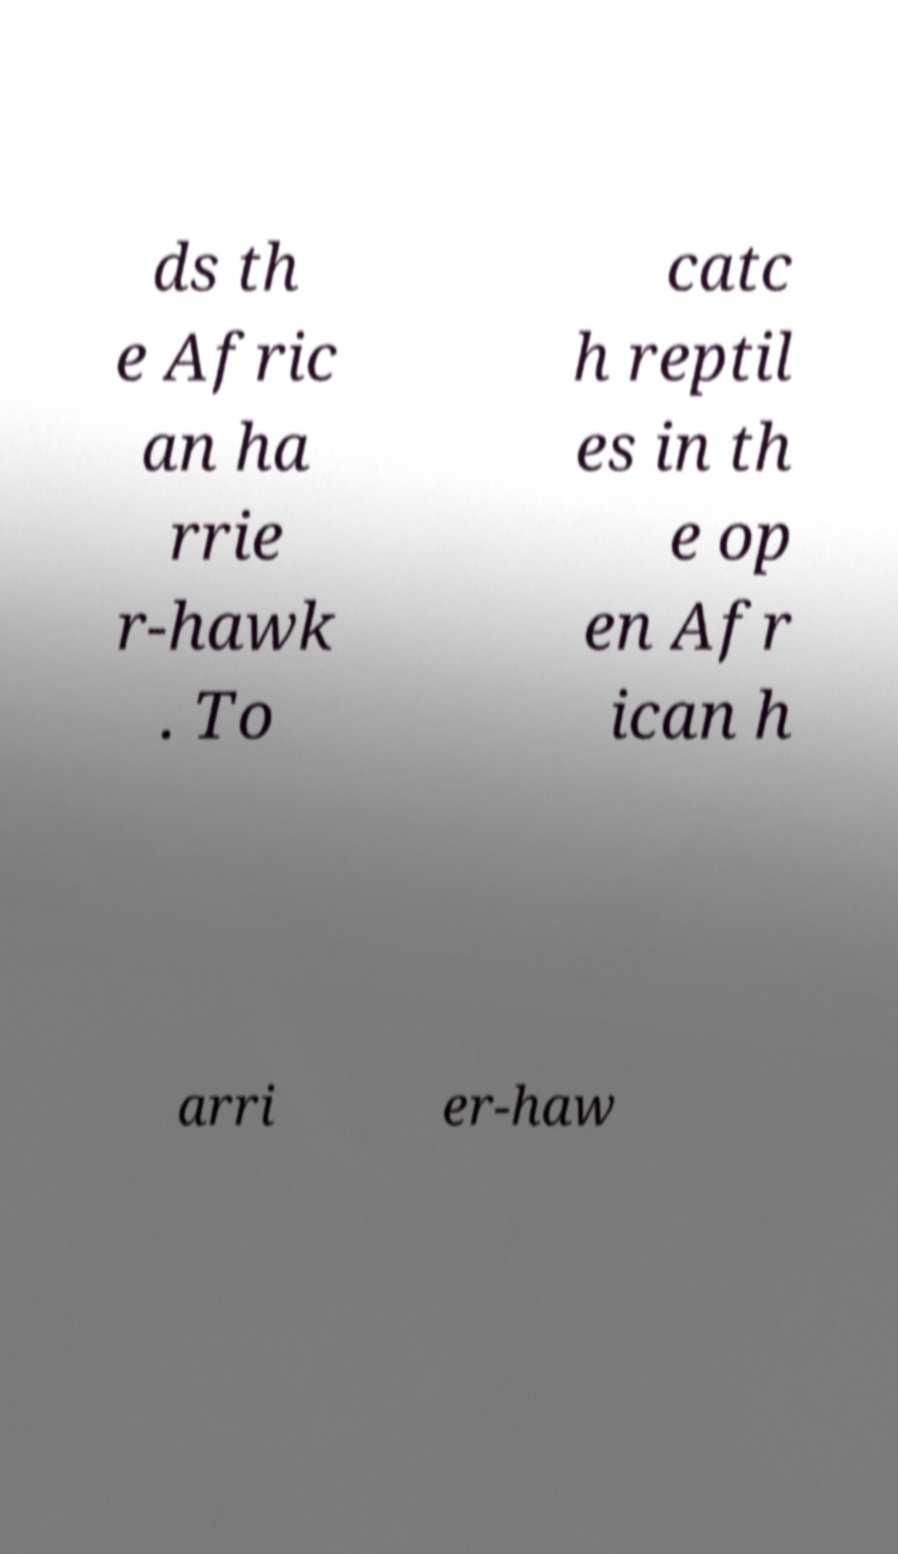What messages or text are displayed in this image? I need them in a readable, typed format. ds th e Afric an ha rrie r-hawk . To catc h reptil es in th e op en Afr ican h arri er-haw 